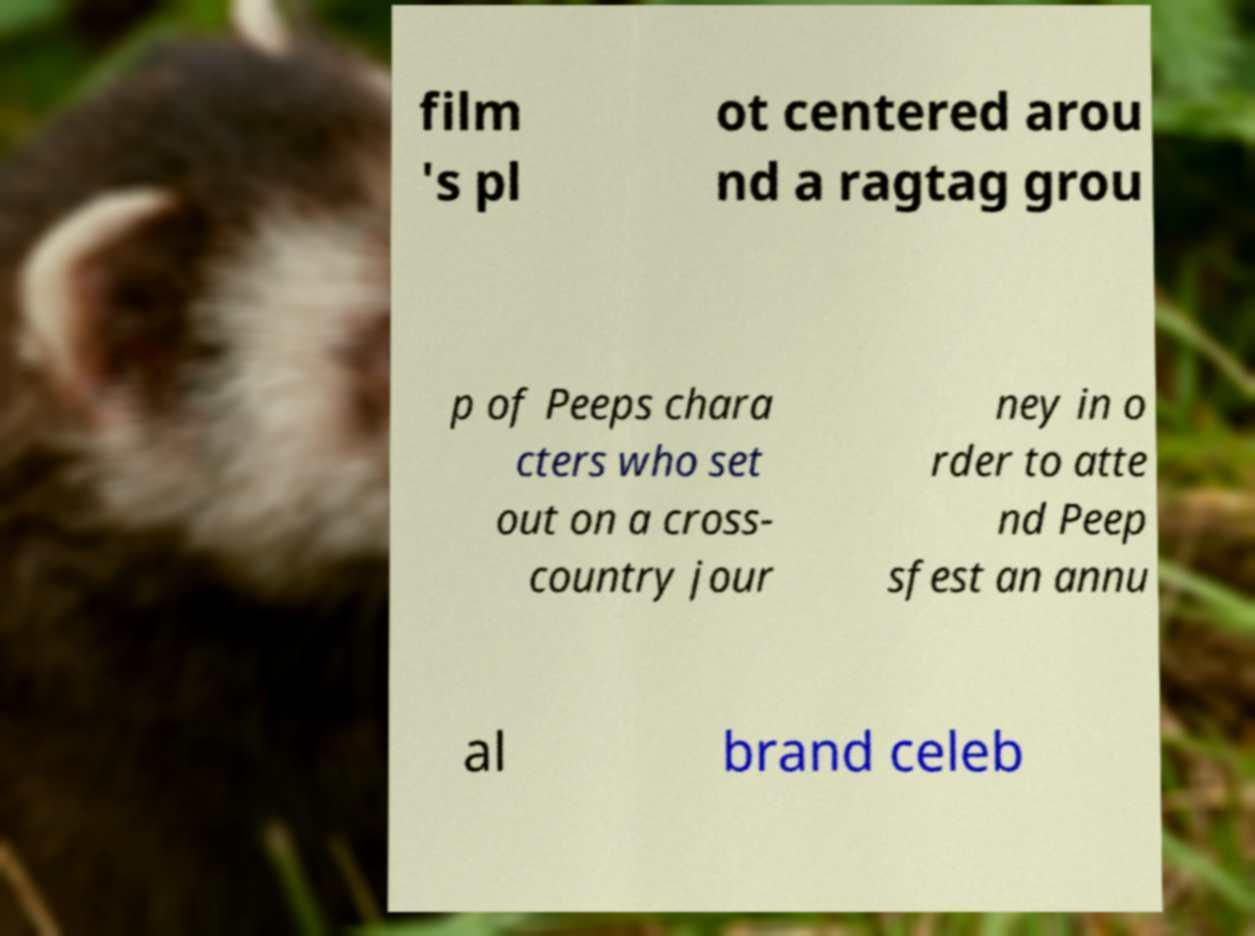What messages or text are displayed in this image? I need them in a readable, typed format. film 's pl ot centered arou nd a ragtag grou p of Peeps chara cters who set out on a cross- country jour ney in o rder to atte nd Peep sfest an annu al brand celeb 